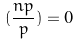<formula> <loc_0><loc_0><loc_500><loc_500>( \frac { n p } { p } ) = 0</formula> 